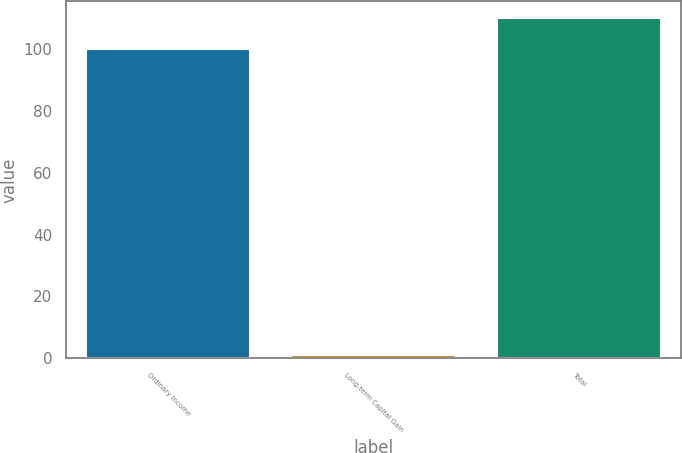Convert chart. <chart><loc_0><loc_0><loc_500><loc_500><bar_chart><fcel>Ordinary Income<fcel>Long-term Capital Gain<fcel>Total<nl><fcel>100<fcel>1.01<fcel>109.9<nl></chart> 